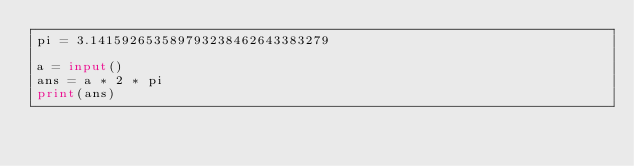Convert code to text. <code><loc_0><loc_0><loc_500><loc_500><_Python_>pi = 3.141592653589793238462643383279

a = input()
ans = a * 2 * pi
print(ans)</code> 